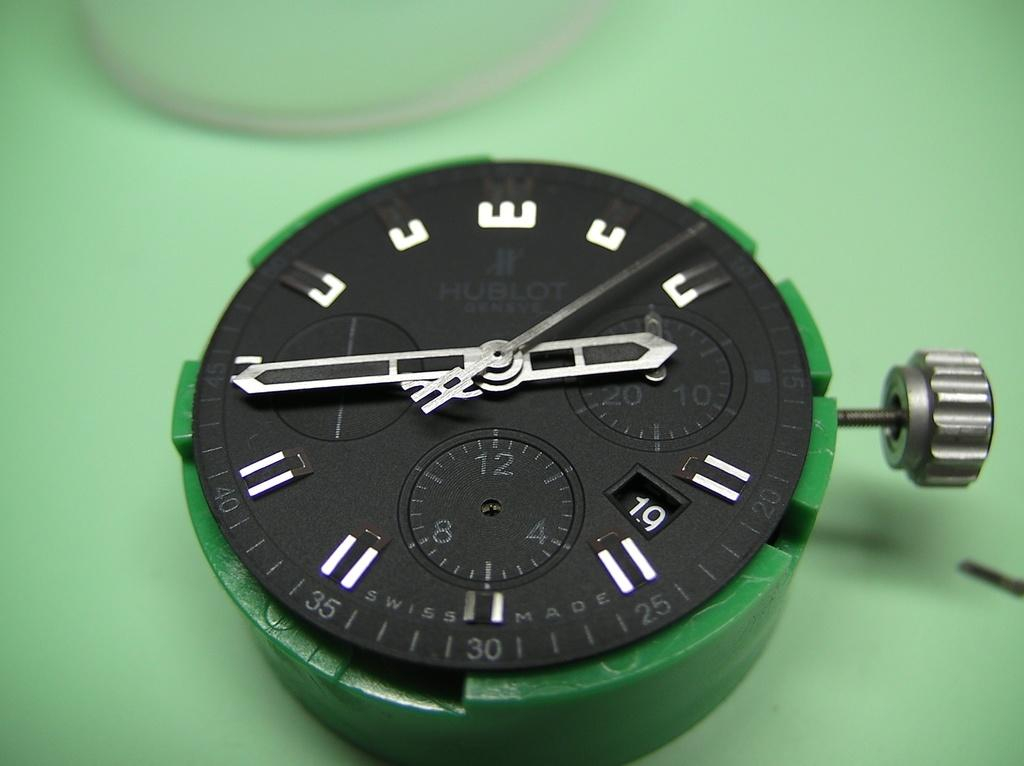<image>
Provide a brief description of the given image. The inside clock piece that has Hublot written on it. 